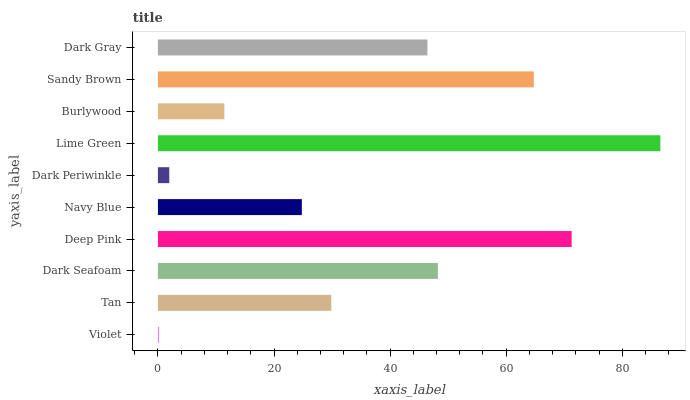Is Violet the minimum?
Answer yes or no. Yes. Is Lime Green the maximum?
Answer yes or no. Yes. Is Tan the minimum?
Answer yes or no. No. Is Tan the maximum?
Answer yes or no. No. Is Tan greater than Violet?
Answer yes or no. Yes. Is Violet less than Tan?
Answer yes or no. Yes. Is Violet greater than Tan?
Answer yes or no. No. Is Tan less than Violet?
Answer yes or no. No. Is Dark Gray the high median?
Answer yes or no. Yes. Is Tan the low median?
Answer yes or no. Yes. Is Lime Green the high median?
Answer yes or no. No. Is Dark Gray the low median?
Answer yes or no. No. 